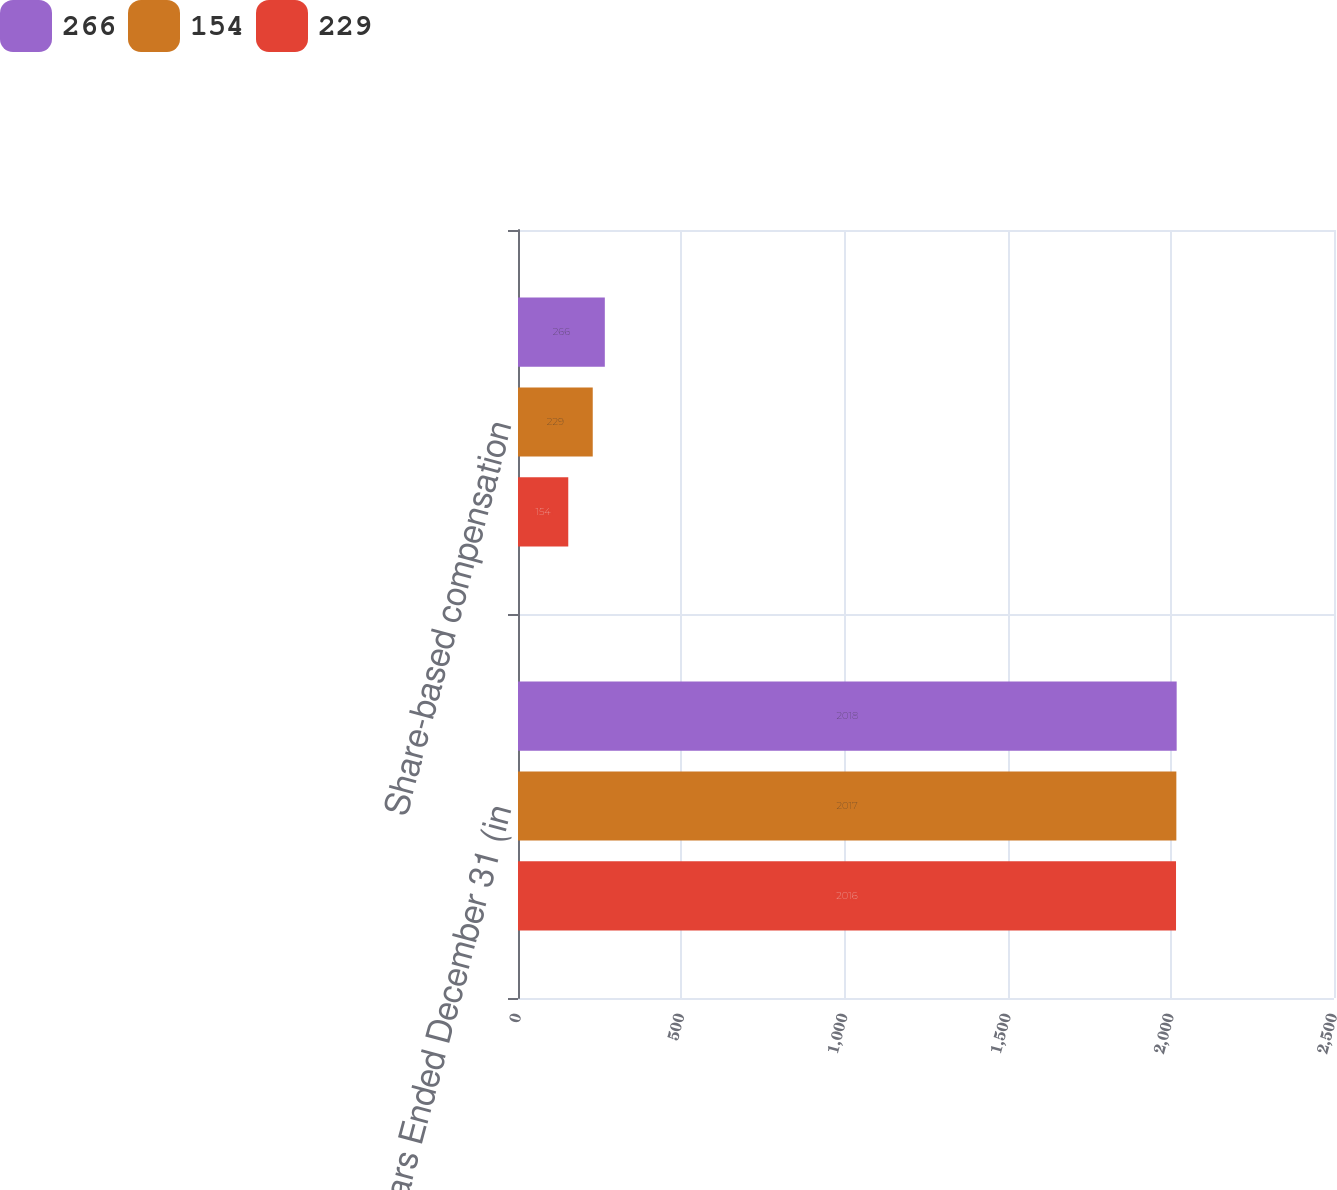Convert chart. <chart><loc_0><loc_0><loc_500><loc_500><stacked_bar_chart><ecel><fcel>Years Ended December 31 (in<fcel>Share-based compensation<nl><fcel>266<fcel>2018<fcel>266<nl><fcel>154<fcel>2017<fcel>229<nl><fcel>229<fcel>2016<fcel>154<nl></chart> 